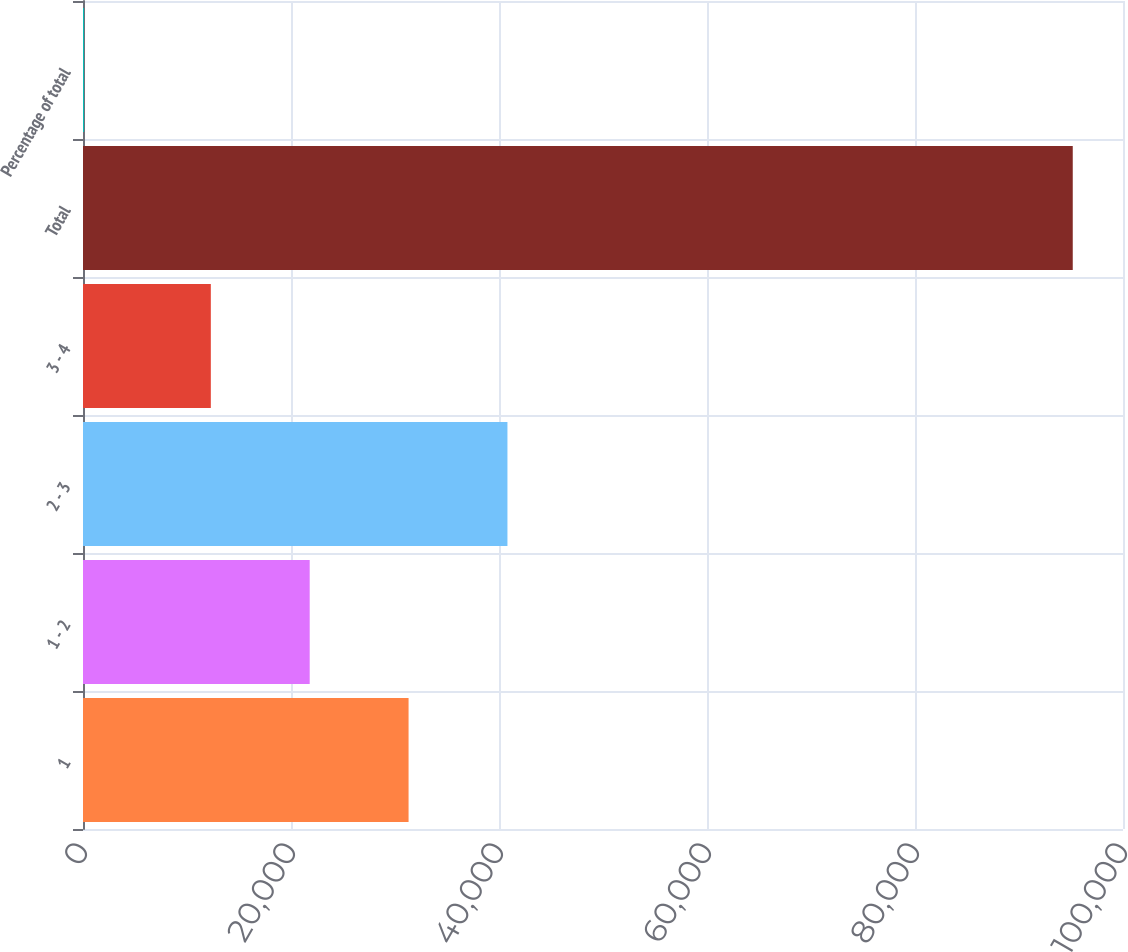<chart> <loc_0><loc_0><loc_500><loc_500><bar_chart><fcel>1<fcel>1 - 2<fcel>2 - 3<fcel>3 - 4<fcel>Total<fcel>Percentage of total<nl><fcel>31304.8<fcel>21797.9<fcel>40811.7<fcel>12291<fcel>95169<fcel>100<nl></chart> 